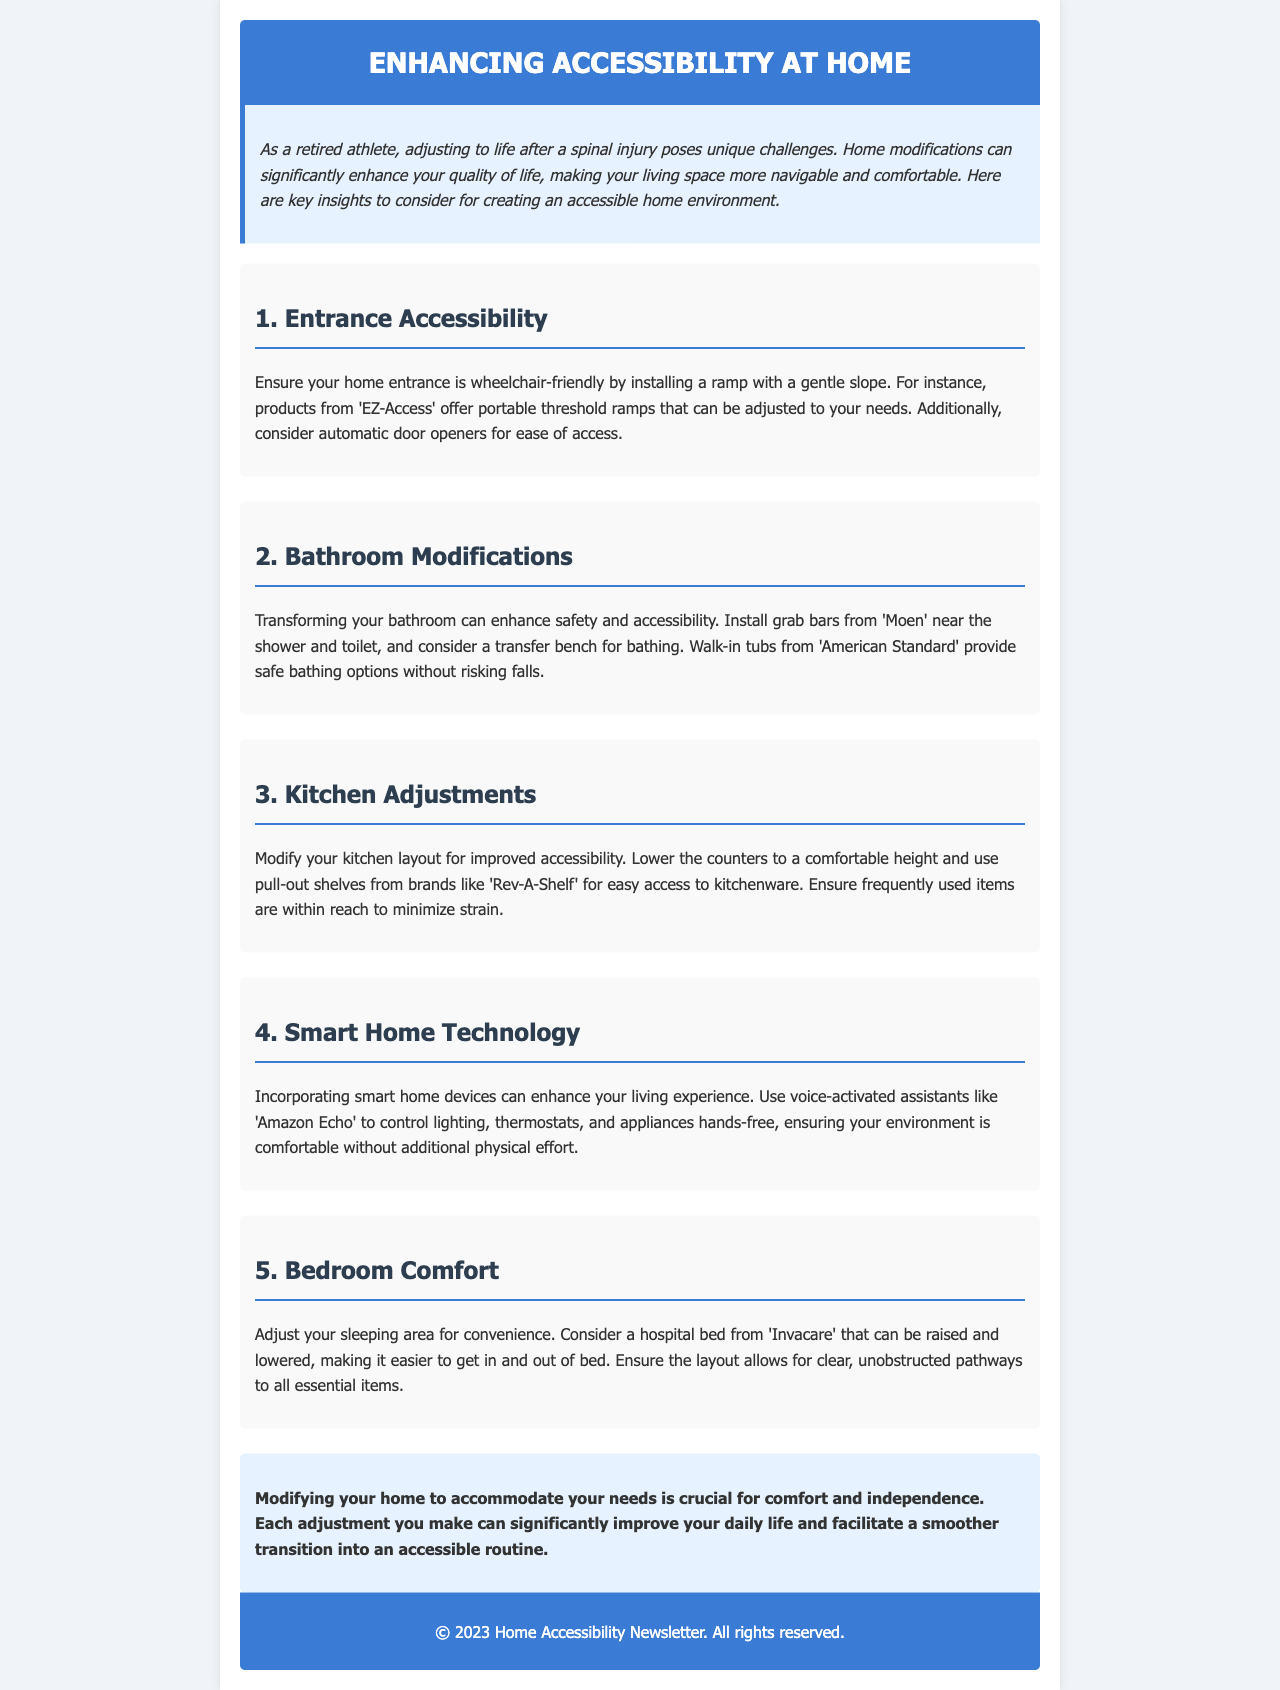What is the title of the newsletter? The title of the newsletter is prominently displayed in the header section.
Answer: Enhancing Accessibility at Home Which company provides portable threshold ramps? The document mentions 'EZ-Access' as the provider of portable threshold ramps.
Answer: EZ-Access What type of technology is recommended for hands-free control? The newsletter suggests using voice-activated assistants for hands-free control.
Answer: Smart home technology What is a suggested product for bath safety? The document recommends installing grab bars from 'Moen' for safety in the bathroom.
Answer: Moen How can kitchen accessibility be improved? The document mentions modifying kitchen layout, including lowering counters and using pull-out shelves, for better accessibility.
Answer: Lower counters and pull-out shelves Why are walk-in tubs suggested? Walk-in tubs are mentioned for providing safe bathing options without risking falls.
Answer: Safe bathing options How can bedroom convenience be adjusted? The document discusses considering a hospital bed that can be raised and lowered for convenience.
Answer: Hospital bed What is the purpose of home modifications according to the conclusion? The conclusion highlights that modifying your home is crucial for comfort and independence.
Answer: Comfort and independence 